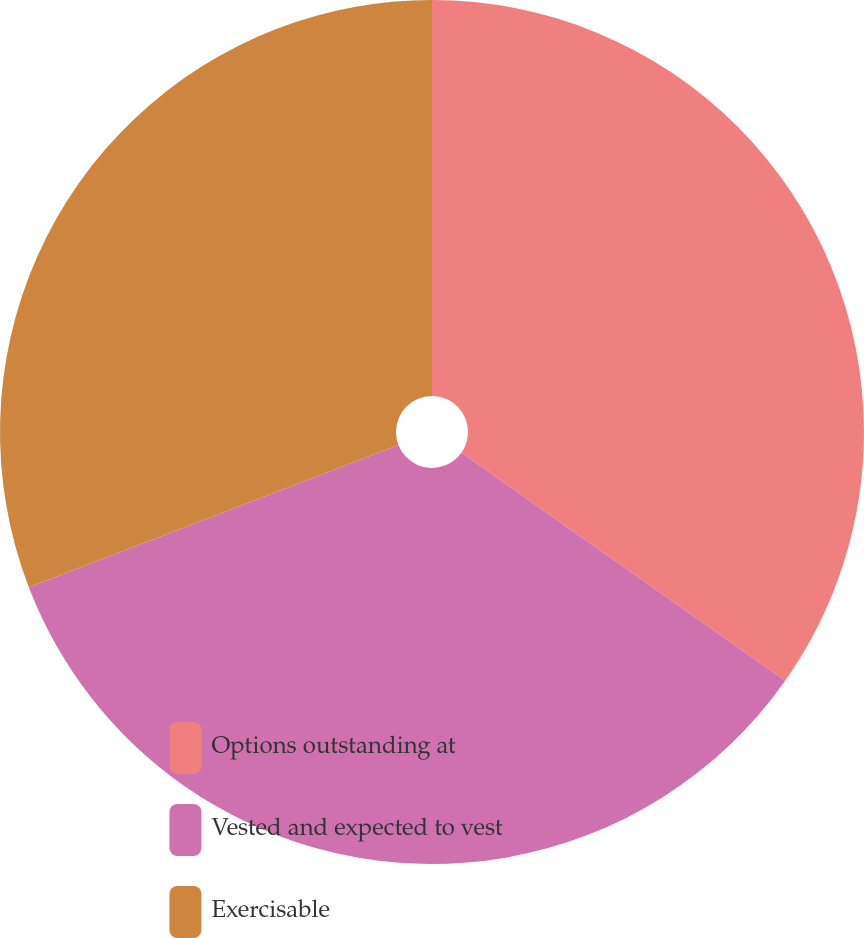Convert chart to OTSL. <chart><loc_0><loc_0><loc_500><loc_500><pie_chart><fcel>Options outstanding at<fcel>Vested and expected to vest<fcel>Exercisable<nl><fcel>34.77%<fcel>34.39%<fcel>30.85%<nl></chart> 